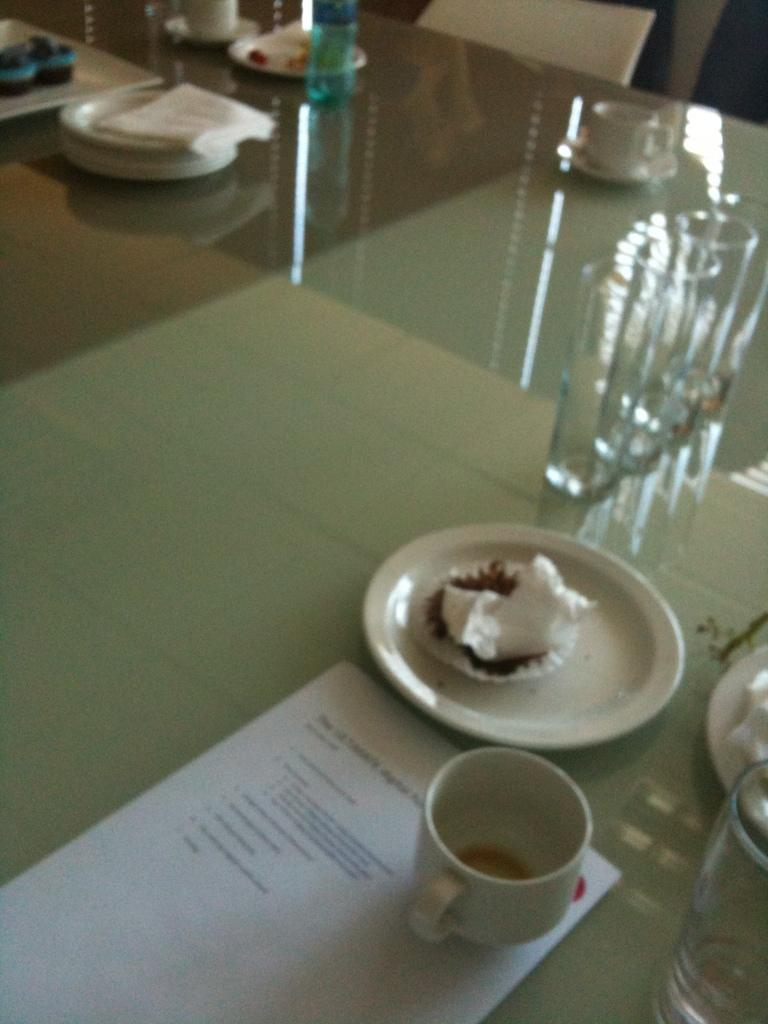What type of furniture is present in the image? There is a table in the image. What items can be seen on the table? There are glasses, cups, plates, napkins, and papers on the table. How many types of tableware are visible on the table? There are three types of tableware visible: glasses, cups, and plates. What type of crime is being investigated in the image? There is no indication of a crime or investigation in the image; it simply shows a table with various items on it. 